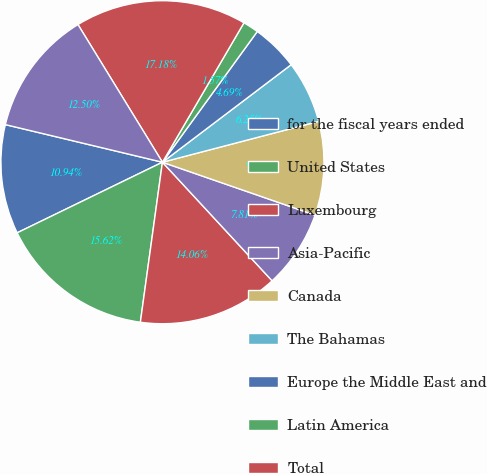<chart> <loc_0><loc_0><loc_500><loc_500><pie_chart><fcel>for the fiscal years ended<fcel>United States<fcel>Luxembourg<fcel>Asia-Pacific<fcel>Canada<fcel>The Bahamas<fcel>Europe the Middle East and<fcel>Latin America<fcel>Total<fcel>as of September 30<nl><fcel>10.94%<fcel>15.62%<fcel>14.06%<fcel>7.81%<fcel>9.38%<fcel>6.25%<fcel>4.69%<fcel>1.57%<fcel>17.18%<fcel>12.5%<nl></chart> 